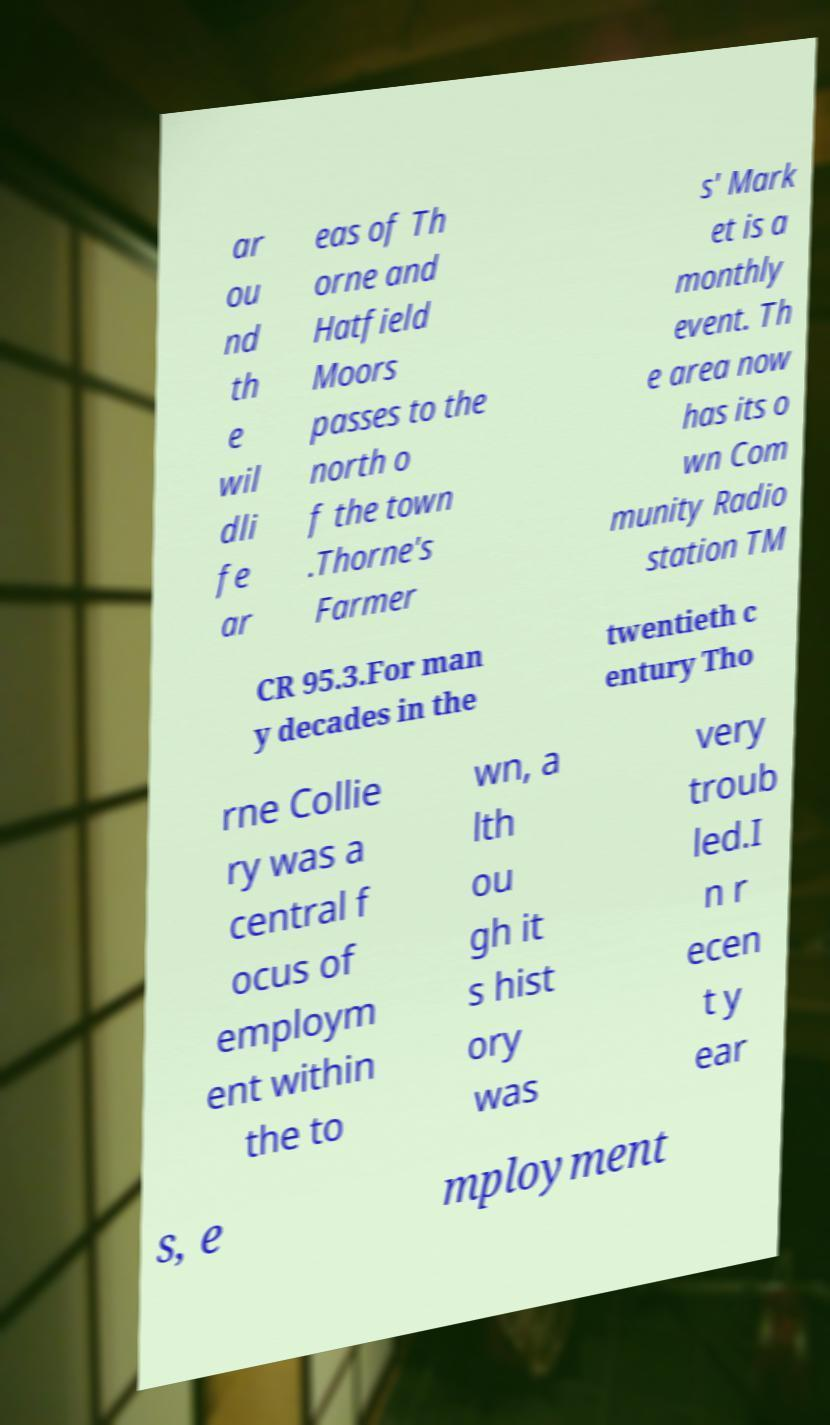For documentation purposes, I need the text within this image transcribed. Could you provide that? ar ou nd th e wil dli fe ar eas of Th orne and Hatfield Moors passes to the north o f the town .Thorne's Farmer s' Mark et is a monthly event. Th e area now has its o wn Com munity Radio station TM CR 95.3.For man y decades in the twentieth c entury Tho rne Collie ry was a central f ocus of employm ent within the to wn, a lth ou gh it s hist ory was very troub led.I n r ecen t y ear s, e mployment 